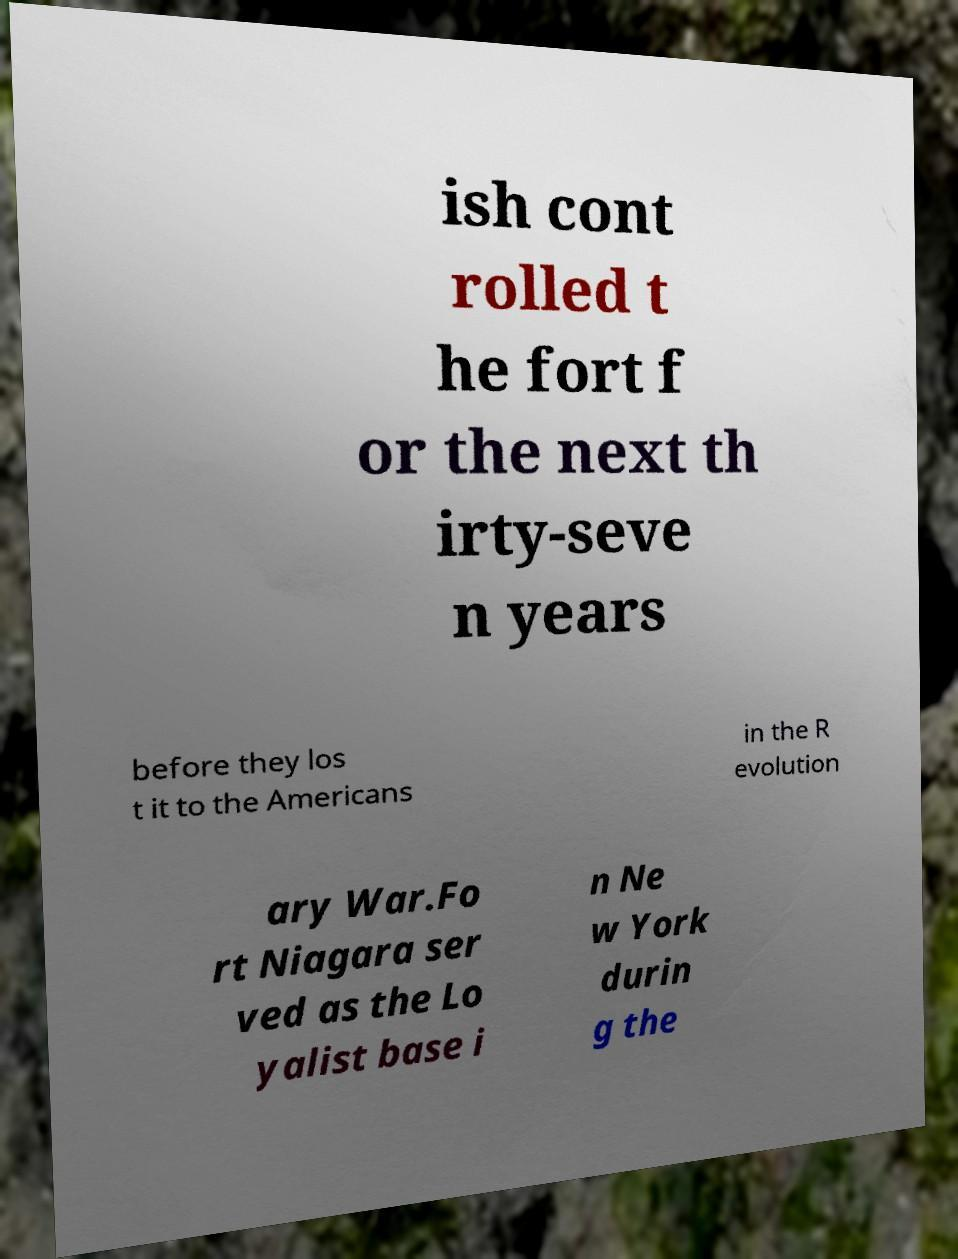For documentation purposes, I need the text within this image transcribed. Could you provide that? ish cont rolled t he fort f or the next th irty-seve n years before they los t it to the Americans in the R evolution ary War.Fo rt Niagara ser ved as the Lo yalist base i n Ne w York durin g the 